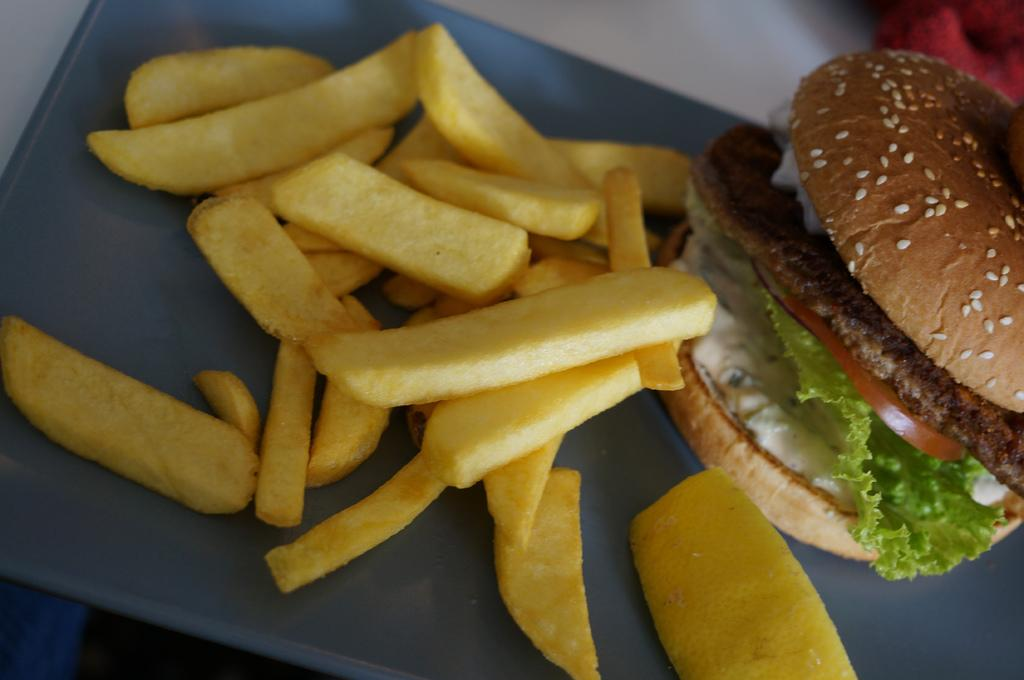What type of food can be seen in the image? There is food in the image, but the specific type is not mentioned. Can you describe the colors of the food? The food has brown, red, and green colors. What is the color of the tray holding the food? The tray holding the food is gray. Are there any clams visible in the image? There is no mention of clams in the image, so it cannot be determined if any are present. Is there a war happening in the image? There is no indication of a war or any conflict in the image. 